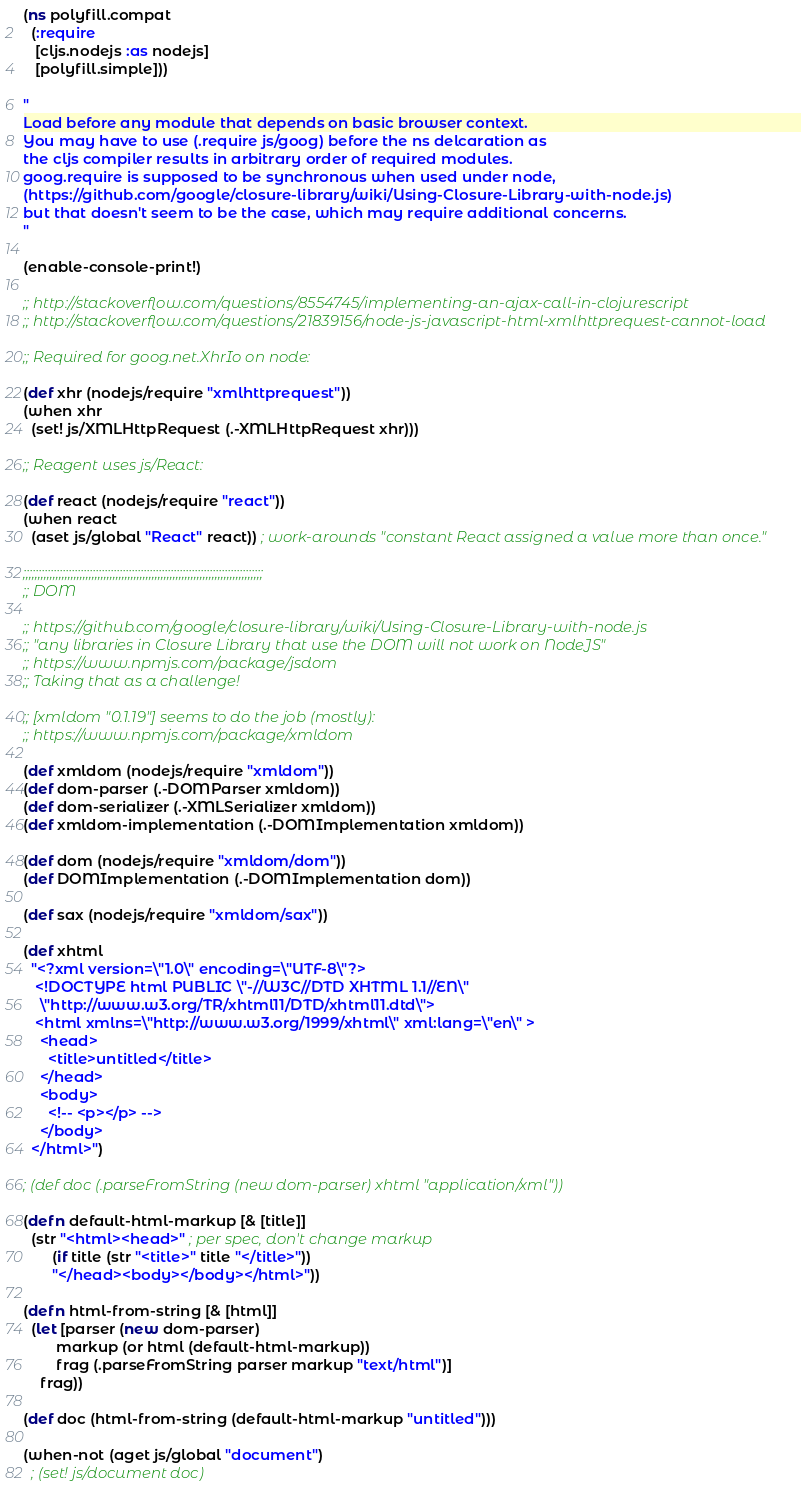<code> <loc_0><loc_0><loc_500><loc_500><_Clojure_>(ns polyfill.compat
  (:require
   [cljs.nodejs :as nodejs]
   [polyfill.simple]))

"
Load before any module that depends on basic browser context.
You may have to use (.require js/goog) before the ns delcaration as
the cljs compiler results in arbitrary order of required modules.
goog.require is supposed to be synchronous when used under node,
(https://github.com/google/closure-library/wiki/Using-Closure-Library-with-node.js)
but that doesn't seem to be the case, which may require additional concerns.
"

(enable-console-print!)

;; http://stackoverflow.com/questions/8554745/implementing-an-ajax-call-in-clojurescript
;; http://stackoverflow.com/questions/21839156/node-js-javascript-html-xmlhttprequest-cannot-load

;; Required for goog.net.XhrIo on node:

(def xhr (nodejs/require "xmlhttprequest"))
(when xhr
  (set! js/XMLHttpRequest (.-XMLHttpRequest xhr)))

;; Reagent uses js/React:

(def react (nodejs/require "react"))
(when react
  (aset js/global "React" react)) ; work-arounds "constant React assigned a value more than once."

;;;;;;;;;;;;;;;;;;;;;;;;;;;;;;;;;;;;;;;;;;;;;;;;;;;;;;;;;;;;;;;;;;;;;;;;;;;;;;;;
;; DOM

;; https://github.com/google/closure-library/wiki/Using-Closure-Library-with-node.js
;; "any libraries in Closure Library that use the DOM will not work on NodeJS"
;; https://www.npmjs.com/package/jsdom
;; Taking that as a challenge!

;; [xmldom "0.1.19"] seems to do the job (mostly):
;; https://www.npmjs.com/package/xmldom

(def xmldom (nodejs/require "xmldom"))
(def dom-parser (.-DOMParser xmldom))
(def dom-serializer (.-XMLSerializer xmldom))
(def xmldom-implementation (.-DOMImplementation xmldom))

(def dom (nodejs/require "xmldom/dom"))
(def DOMImplementation (.-DOMImplementation dom))

(def sax (nodejs/require "xmldom/sax"))

(def xhtml
  "<?xml version=\"1.0\" encoding=\"UTF-8\"?>
   <!DOCTYPE html PUBLIC \"-//W3C//DTD XHTML 1.1//EN\"
    \"http://www.w3.org/TR/xhtml11/DTD/xhtml11.dtd\">
   <html xmlns=\"http://www.w3.org/1999/xhtml\" xml:lang=\"en\" >
    <head>
      <title>untitled</title>
    </head>
    <body>
      <!-- <p></p> -->
    </body>
  </html>")

; (def doc (.parseFromString (new dom-parser) xhtml "application/xml"))

(defn default-html-markup [& [title]]
  (str "<html><head>" ; per spec, don't change markup
       (if title (str "<title>" title "</title>"))
       "</head><body></body></html>"))

(defn html-from-string [& [html]]
  (let [parser (new dom-parser)
        markup (or html (default-html-markup))
        frag (.parseFromString parser markup "text/html")]
    frag))

(def doc (html-from-string (default-html-markup "untitled")))

(when-not (aget js/global "document")
  ; (set! js/document doc)</code> 